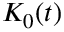<formula> <loc_0><loc_0><loc_500><loc_500>K _ { 0 } ( t )</formula> 